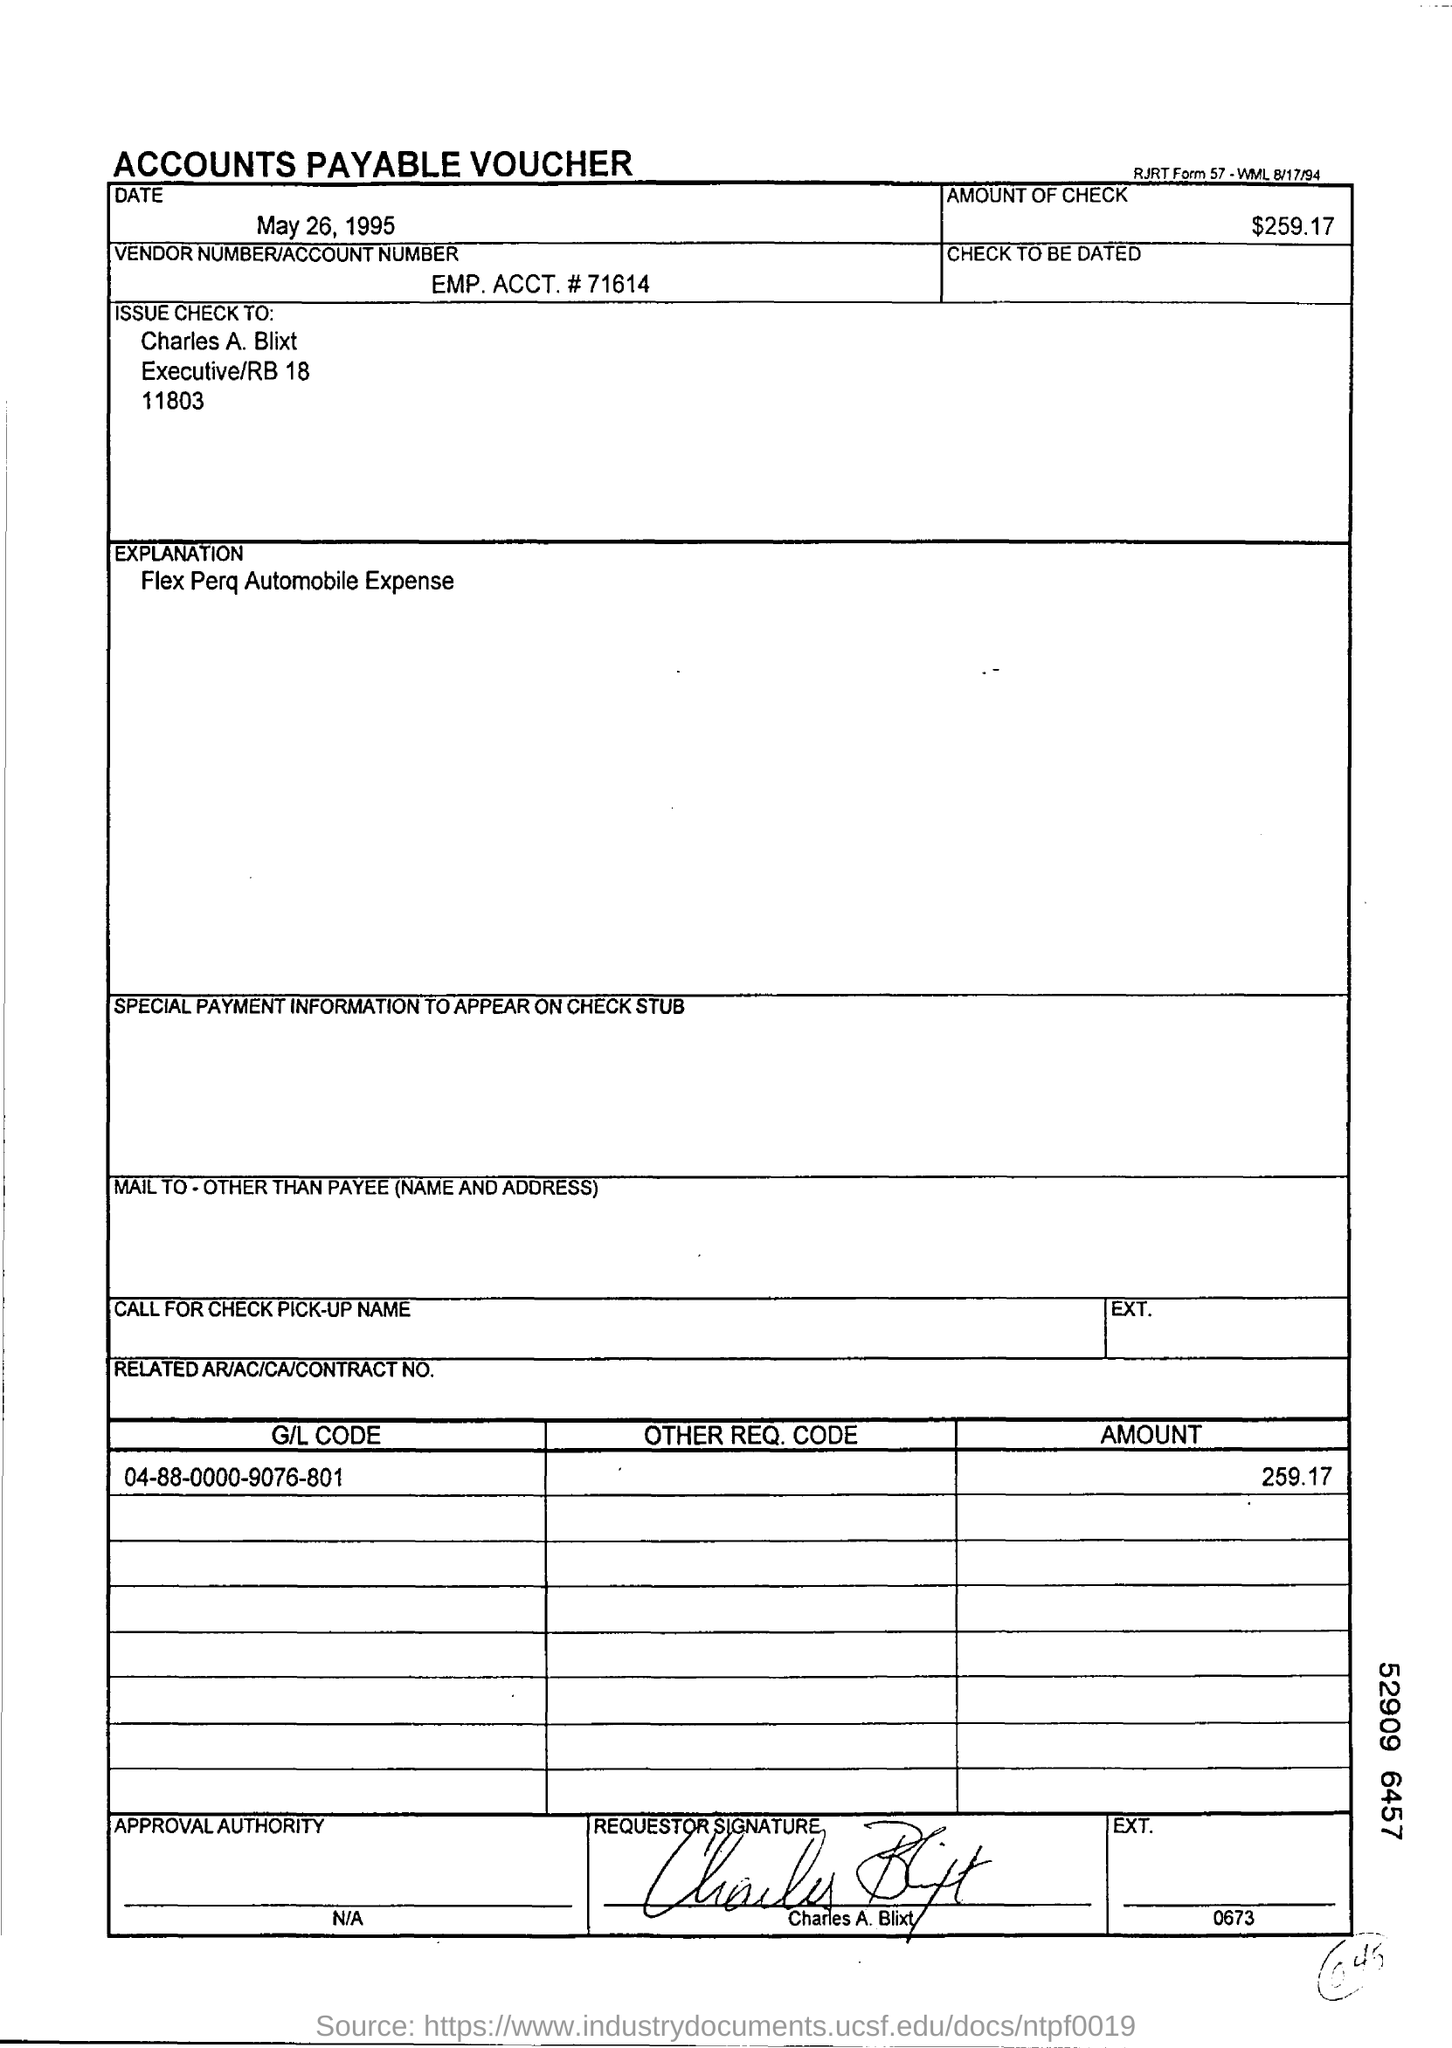What type of documentation is this?
Your response must be concise. ACCOUNTS PAYABLE VOUCHER. When is the document dated?
Keep it short and to the point. May 26, 1995. What is the amount of check?
Your answer should be compact. $259.17. What is the vendor number/account number?
Ensure brevity in your answer.  EMP. ACCT. # 71614. To whom should the check be issued?
Give a very brief answer. Charles A. Blixt. What is the explanation given?
Your response must be concise. Flex Perq Automobile Expense. What is the G/L Code mentioned?
Ensure brevity in your answer.  04-88-0000-9076-801. 